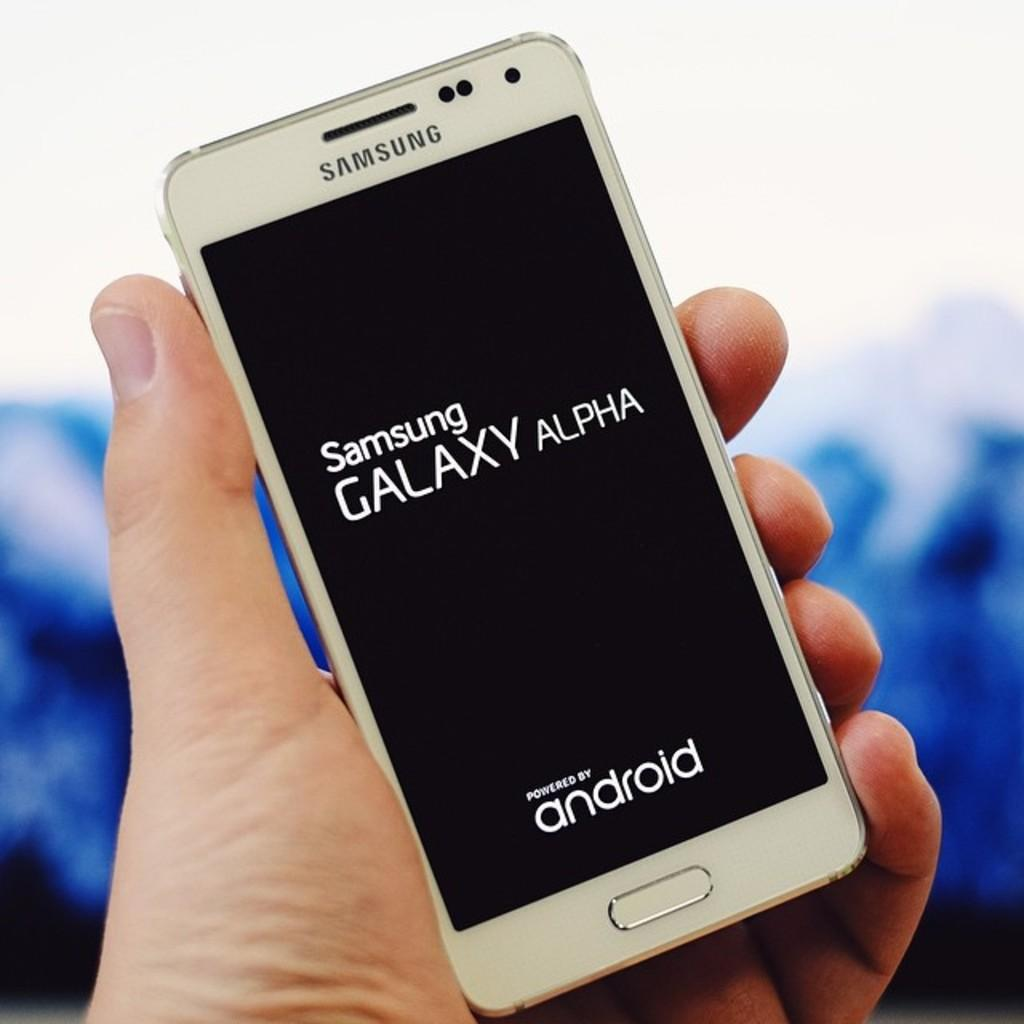What electronic device is visible in the image? There is a mobile phone in the image. Who is holding the mobile phone in the image? The mobile phone is in a person's hand. Where is the mobile phone located in the image? The mobile phone is in the center of the image. What type of muscle is being exercised by the person holding the mobile phone in the image? There is no indication in the image of any muscle being exercised, as the focus is on the mobile phone. Is the mobile phone capable of flight in the image? The mobile phone is not capable of flight in the image, as it is being held by a person. 